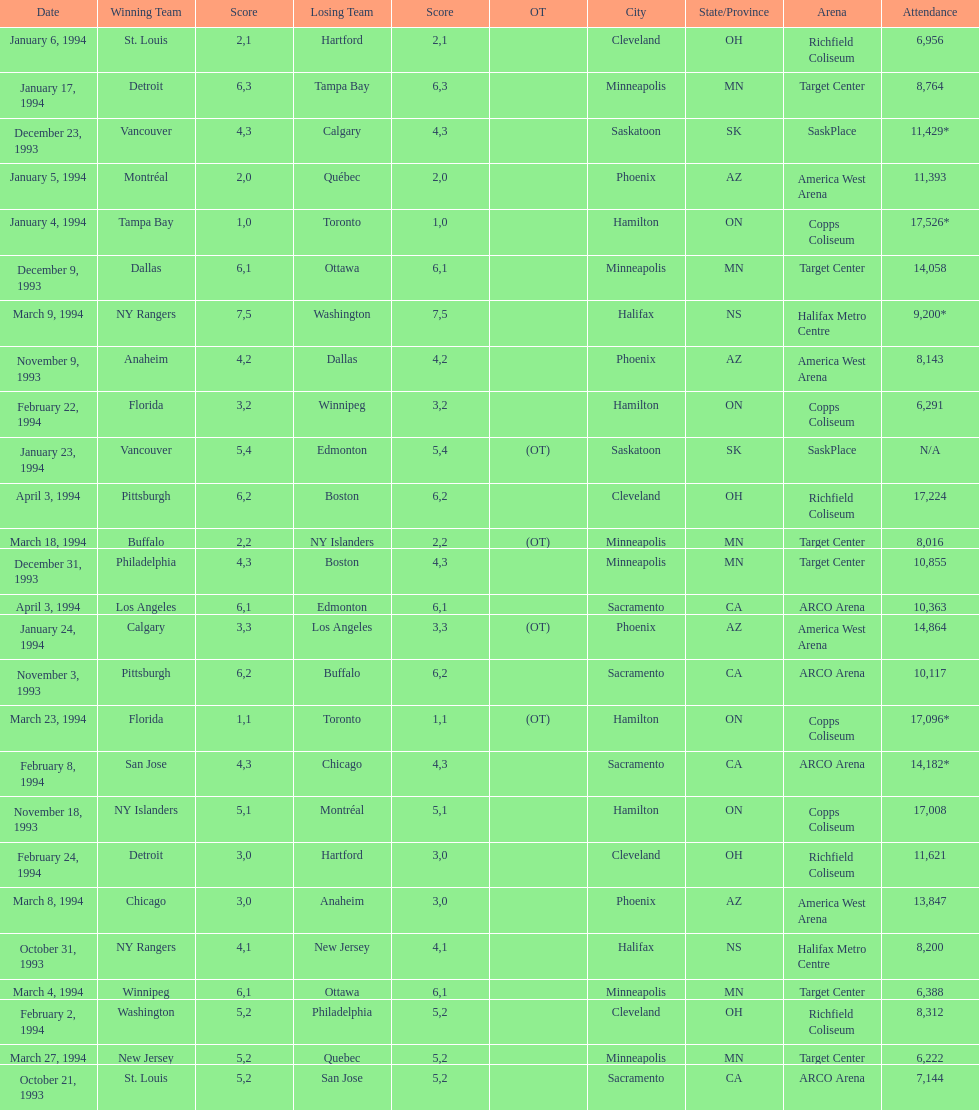Did dallas or ottawa win the december 9, 1993 game? Dallas. Could you help me parse every detail presented in this table? {'header': ['Date', 'Winning Team', 'Score', 'Losing Team', 'Score', 'OT', 'City', 'State/Province', 'Arena', 'Attendance'], 'rows': [['January 6, 1994', 'St. Louis', '2', 'Hartford', '1', '', 'Cleveland', 'OH', 'Richfield Coliseum', '6,956'], ['January 17, 1994', 'Detroit', '6', 'Tampa Bay', '3', '', 'Minneapolis', 'MN', 'Target Center', '8,764'], ['December 23, 1993', 'Vancouver', '4', 'Calgary', '3', '', 'Saskatoon', 'SK', 'SaskPlace', '11,429*'], ['January 5, 1994', 'Montréal', '2', 'Québec', '0', '', 'Phoenix', 'AZ', 'America West Arena', '11,393'], ['January 4, 1994', 'Tampa Bay', '1', 'Toronto', '0', '', 'Hamilton', 'ON', 'Copps Coliseum', '17,526*'], ['December 9, 1993', 'Dallas', '6', 'Ottawa', '1', '', 'Minneapolis', 'MN', 'Target Center', '14,058'], ['March 9, 1994', 'NY Rangers', '7', 'Washington', '5', '', 'Halifax', 'NS', 'Halifax Metro Centre', '9,200*'], ['November 9, 1993', 'Anaheim', '4', 'Dallas', '2', '', 'Phoenix', 'AZ', 'America West Arena', '8,143'], ['February 22, 1994', 'Florida', '3', 'Winnipeg', '2', '', 'Hamilton', 'ON', 'Copps Coliseum', '6,291'], ['January 23, 1994', 'Vancouver', '5', 'Edmonton', '4', '(OT)', 'Saskatoon', 'SK', 'SaskPlace', 'N/A'], ['April 3, 1994', 'Pittsburgh', '6', 'Boston', '2', '', 'Cleveland', 'OH', 'Richfield Coliseum', '17,224'], ['March 18, 1994', 'Buffalo', '2', 'NY Islanders', '2', '(OT)', 'Minneapolis', 'MN', 'Target Center', '8,016'], ['December 31, 1993', 'Philadelphia', '4', 'Boston', '3', '', 'Minneapolis', 'MN', 'Target Center', '10,855'], ['April 3, 1994', 'Los Angeles', '6', 'Edmonton', '1', '', 'Sacramento', 'CA', 'ARCO Arena', '10,363'], ['January 24, 1994', 'Calgary', '3', 'Los Angeles', '3', '(OT)', 'Phoenix', 'AZ', 'America West Arena', '14,864'], ['November 3, 1993', 'Pittsburgh', '6', 'Buffalo', '2', '', 'Sacramento', 'CA', 'ARCO Arena', '10,117'], ['March 23, 1994', 'Florida', '1', 'Toronto', '1', '(OT)', 'Hamilton', 'ON', 'Copps Coliseum', '17,096*'], ['February 8, 1994', 'San Jose', '4', 'Chicago', '3', '', 'Sacramento', 'CA', 'ARCO Arena', '14,182*'], ['November 18, 1993', 'NY Islanders', '5', 'Montréal', '1', '', 'Hamilton', 'ON', 'Copps Coliseum', '17,008'], ['February 24, 1994', 'Detroit', '3', 'Hartford', '0', '', 'Cleveland', 'OH', 'Richfield Coliseum', '11,621'], ['March 8, 1994', 'Chicago', '3', 'Anaheim', '0', '', 'Phoenix', 'AZ', 'America West Arena', '13,847'], ['October 31, 1993', 'NY Rangers', '4', 'New Jersey', '1', '', 'Halifax', 'NS', 'Halifax Metro Centre', '8,200'], ['March 4, 1994', 'Winnipeg', '6', 'Ottawa', '1', '', 'Minneapolis', 'MN', 'Target Center', '6,388'], ['February 2, 1994', 'Washington', '5', 'Philadelphia', '2', '', 'Cleveland', 'OH', 'Richfield Coliseum', '8,312'], ['March 27, 1994', 'New Jersey', '5', 'Quebec', '2', '', 'Minneapolis', 'MN', 'Target Center', '6,222'], ['October 21, 1993', 'St. Louis', '5', 'San Jose', '2', '', 'Sacramento', 'CA', 'ARCO Arena', '7,144']]} 